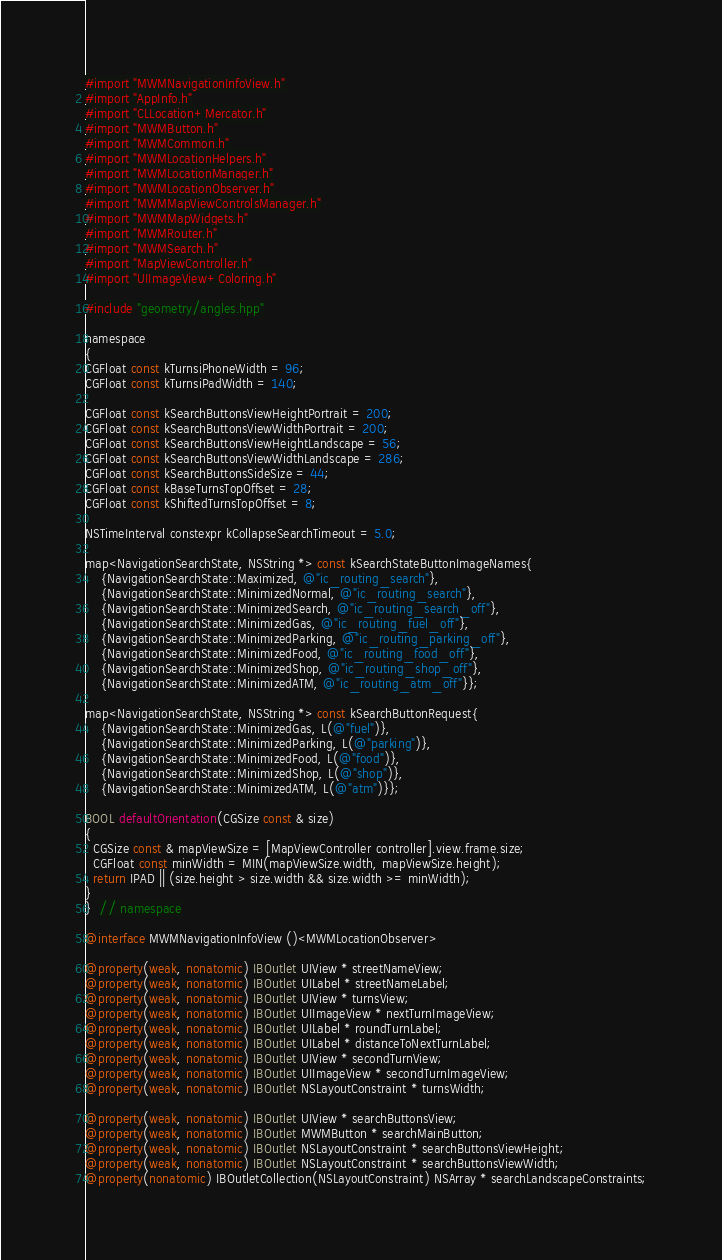Convert code to text. <code><loc_0><loc_0><loc_500><loc_500><_ObjectiveC_>#import "MWMNavigationInfoView.h"
#import "AppInfo.h"
#import "CLLocation+Mercator.h"
#import "MWMButton.h"
#import "MWMCommon.h"
#import "MWMLocationHelpers.h"
#import "MWMLocationManager.h"
#import "MWMLocationObserver.h"
#import "MWMMapViewControlsManager.h"
#import "MWMMapWidgets.h"
#import "MWMRouter.h"
#import "MWMSearch.h"
#import "MapViewController.h"
#import "UIImageView+Coloring.h"

#include "geometry/angles.hpp"

namespace
{
CGFloat const kTurnsiPhoneWidth = 96;
CGFloat const kTurnsiPadWidth = 140;

CGFloat const kSearchButtonsViewHeightPortrait = 200;
CGFloat const kSearchButtonsViewWidthPortrait = 200;
CGFloat const kSearchButtonsViewHeightLandscape = 56;
CGFloat const kSearchButtonsViewWidthLandscape = 286;
CGFloat const kSearchButtonsSideSize = 44;
CGFloat const kBaseTurnsTopOffset = 28;
CGFloat const kShiftedTurnsTopOffset = 8;

NSTimeInterval constexpr kCollapseSearchTimeout = 5.0;

map<NavigationSearchState, NSString *> const kSearchStateButtonImageNames{
    {NavigationSearchState::Maximized, @"ic_routing_search"},
    {NavigationSearchState::MinimizedNormal, @"ic_routing_search"},
    {NavigationSearchState::MinimizedSearch, @"ic_routing_search_off"},
    {NavigationSearchState::MinimizedGas, @"ic_routing_fuel_off"},
    {NavigationSearchState::MinimizedParking, @"ic_routing_parking_off"},
    {NavigationSearchState::MinimizedFood, @"ic_routing_food_off"},
    {NavigationSearchState::MinimizedShop, @"ic_routing_shop_off"},
    {NavigationSearchState::MinimizedATM, @"ic_routing_atm_off"}};

map<NavigationSearchState, NSString *> const kSearchButtonRequest{
    {NavigationSearchState::MinimizedGas, L(@"fuel")},
    {NavigationSearchState::MinimizedParking, L(@"parking")},
    {NavigationSearchState::MinimizedFood, L(@"food")},
    {NavigationSearchState::MinimizedShop, L(@"shop")},
    {NavigationSearchState::MinimizedATM, L(@"atm")}};

BOOL defaultOrientation(CGSize const & size)
{
  CGSize const & mapViewSize = [MapViewController controller].view.frame.size;
  CGFloat const minWidth = MIN(mapViewSize.width, mapViewSize.height);
  return IPAD || (size.height > size.width && size.width >= minWidth);
}
}  // namespace

@interface MWMNavigationInfoView ()<MWMLocationObserver>

@property(weak, nonatomic) IBOutlet UIView * streetNameView;
@property(weak, nonatomic) IBOutlet UILabel * streetNameLabel;
@property(weak, nonatomic) IBOutlet UIView * turnsView;
@property(weak, nonatomic) IBOutlet UIImageView * nextTurnImageView;
@property(weak, nonatomic) IBOutlet UILabel * roundTurnLabel;
@property(weak, nonatomic) IBOutlet UILabel * distanceToNextTurnLabel;
@property(weak, nonatomic) IBOutlet UIView * secondTurnView;
@property(weak, nonatomic) IBOutlet UIImageView * secondTurnImageView;
@property(weak, nonatomic) IBOutlet NSLayoutConstraint * turnsWidth;

@property(weak, nonatomic) IBOutlet UIView * searchButtonsView;
@property(weak, nonatomic) IBOutlet MWMButton * searchMainButton;
@property(weak, nonatomic) IBOutlet NSLayoutConstraint * searchButtonsViewHeight;
@property(weak, nonatomic) IBOutlet NSLayoutConstraint * searchButtonsViewWidth;
@property(nonatomic) IBOutletCollection(NSLayoutConstraint) NSArray * searchLandscapeConstraints;</code> 